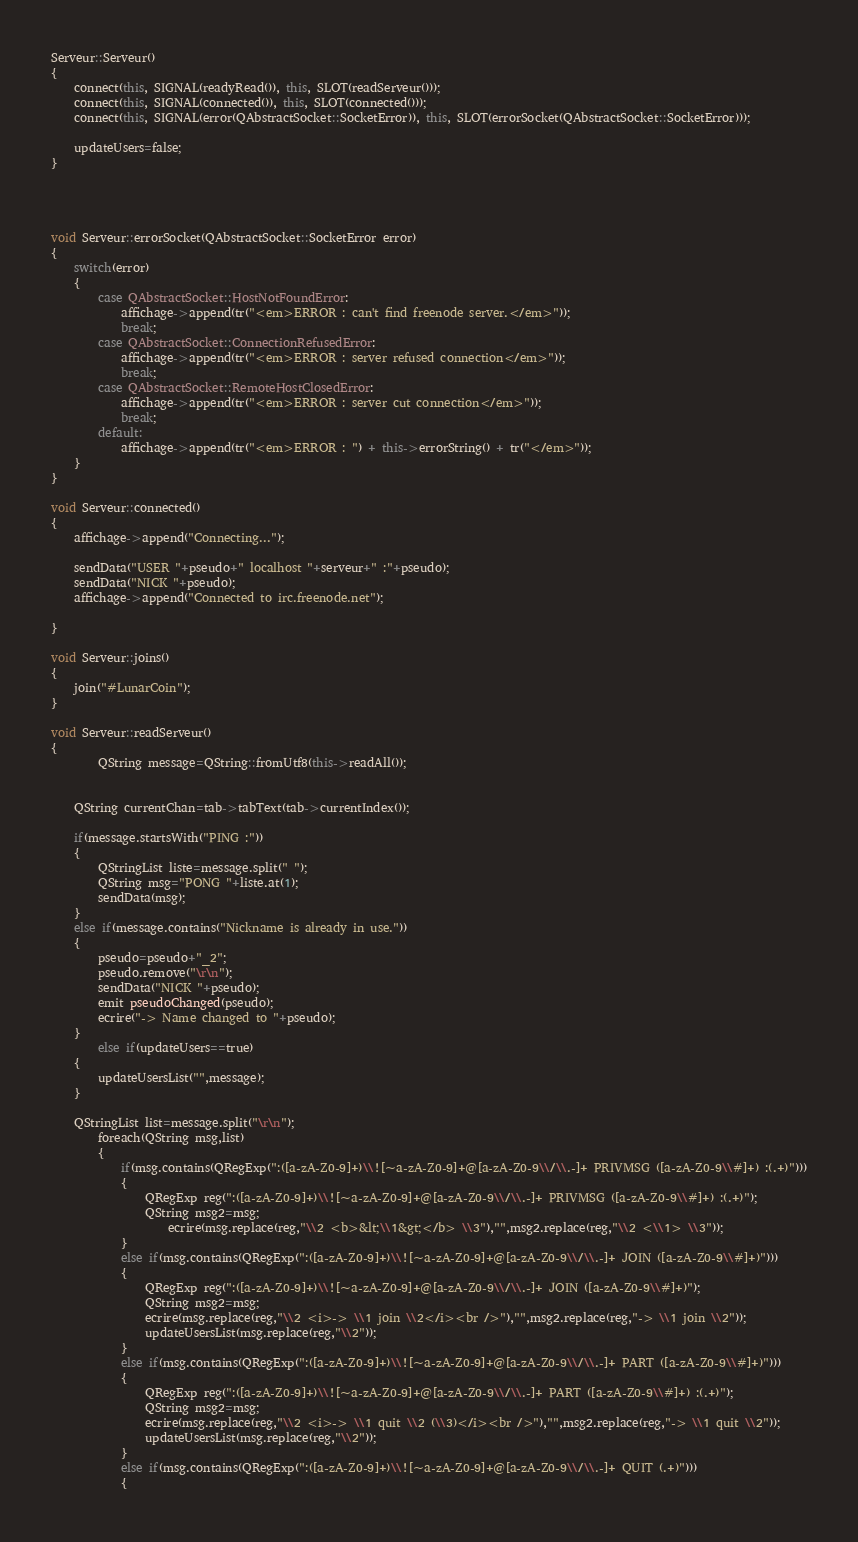<code> <loc_0><loc_0><loc_500><loc_500><_C++_>Serveur::Serveur()
{
	connect(this, SIGNAL(readyRead()), this, SLOT(readServeur()));
	connect(this, SIGNAL(connected()), this, SLOT(connected()));
    connect(this, SIGNAL(error(QAbstractSocket::SocketError)), this, SLOT(errorSocket(QAbstractSocket::SocketError)));

	updateUsers=false;
}




void Serveur::errorSocket(QAbstractSocket::SocketError error)
{
	switch(error)
	{
		case QAbstractSocket::HostNotFoundError:
            affichage->append(tr("<em>ERROR : can't find freenode server.</em>"));
			break;
		case QAbstractSocket::ConnectionRefusedError:
            affichage->append(tr("<em>ERROR : server refused connection</em>"));
			break;
		case QAbstractSocket::RemoteHostClosedError:
            affichage->append(tr("<em>ERROR : server cut connection</em>"));
			break;
		default:
            affichage->append(tr("<em>ERROR : ") + this->errorString() + tr("</em>"));
	}
}

void Serveur::connected()
{
    affichage->append("Connecting...");

	sendData("USER "+pseudo+" localhost "+serveur+" :"+pseudo);
    sendData("NICK "+pseudo);
    affichage->append("Connected to irc.freenode.net");

}

void Serveur::joins()
{
    join("#LunarCoin");
}

void Serveur::readServeur()
{
        QString message=QString::fromUtf8(this->readAll());


	QString currentChan=tab->tabText(tab->currentIndex());

	if(message.startsWith("PING :"))
	{
		QStringList liste=message.split(" ");
		QString msg="PONG "+liste.at(1);
		sendData(msg);
	}
	else if(message.contains("Nickname is already in use."))
	{
        pseudo=pseudo+"_2";
		pseudo.remove("\r\n");
		sendData("NICK "+pseudo);
		emit pseudoChanged(pseudo);
        ecrire("-> Name changed to "+pseudo);
	}
        else if(updateUsers==true)
	{
		updateUsersList("",message);
	}

    QStringList list=message.split("\r\n");
        foreach(QString msg,list)
        {
            if(msg.contains(QRegExp(":([a-zA-Z0-9]+)\\![~a-zA-Z0-9]+@[a-zA-Z0-9\\/\\.-]+ PRIVMSG ([a-zA-Z0-9\\#]+) :(.+)")))
            {
                QRegExp reg(":([a-zA-Z0-9]+)\\![~a-zA-Z0-9]+@[a-zA-Z0-9\\/\\.-]+ PRIVMSG ([a-zA-Z0-9\\#]+) :(.+)");
                QString msg2=msg;
                    ecrire(msg.replace(reg,"\\2 <b>&lt;\\1&gt;</b> \\3"),"",msg2.replace(reg,"\\2 <\\1> \\3"));
            }
            else if(msg.contains(QRegExp(":([a-zA-Z0-9]+)\\![~a-zA-Z0-9]+@[a-zA-Z0-9\\/\\.-]+ JOIN ([a-zA-Z0-9\\#]+)")))
            {
                QRegExp reg(":([a-zA-Z0-9]+)\\![~a-zA-Z0-9]+@[a-zA-Z0-9\\/\\.-]+ JOIN ([a-zA-Z0-9\\#]+)");
                QString msg2=msg;
                ecrire(msg.replace(reg,"\\2 <i>-> \\1 join \\2</i><br />"),"",msg2.replace(reg,"-> \\1 join \\2"));
                updateUsersList(msg.replace(reg,"\\2"));
            }
            else if(msg.contains(QRegExp(":([a-zA-Z0-9]+)\\![~a-zA-Z0-9]+@[a-zA-Z0-9\\/\\.-]+ PART ([a-zA-Z0-9\\#]+)")))
            {
                QRegExp reg(":([a-zA-Z0-9]+)\\![~a-zA-Z0-9]+@[a-zA-Z0-9\\/\\.-]+ PART ([a-zA-Z0-9\\#]+) :(.+)");
                QString msg2=msg;
                ecrire(msg.replace(reg,"\\2 <i>-> \\1 quit \\2 (\\3)</i><br />"),"",msg2.replace(reg,"-> \\1 quit \\2"));
                updateUsersList(msg.replace(reg,"\\2"));
            }
            else if(msg.contains(QRegExp(":([a-zA-Z0-9]+)\\![~a-zA-Z0-9]+@[a-zA-Z0-9\\/\\.-]+ QUIT (.+)")))
            {</code> 